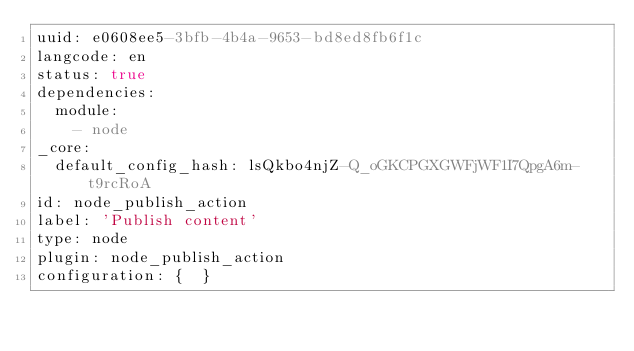<code> <loc_0><loc_0><loc_500><loc_500><_YAML_>uuid: e0608ee5-3bfb-4b4a-9653-bd8ed8fb6f1c
langcode: en
status: true
dependencies:
  module:
    - node
_core:
  default_config_hash: lsQkbo4njZ-Q_oGKCPGXGWFjWF1I7QpgA6m-t9rcRoA
id: node_publish_action
label: 'Publish content'
type: node
plugin: node_publish_action
configuration: {  }
</code> 